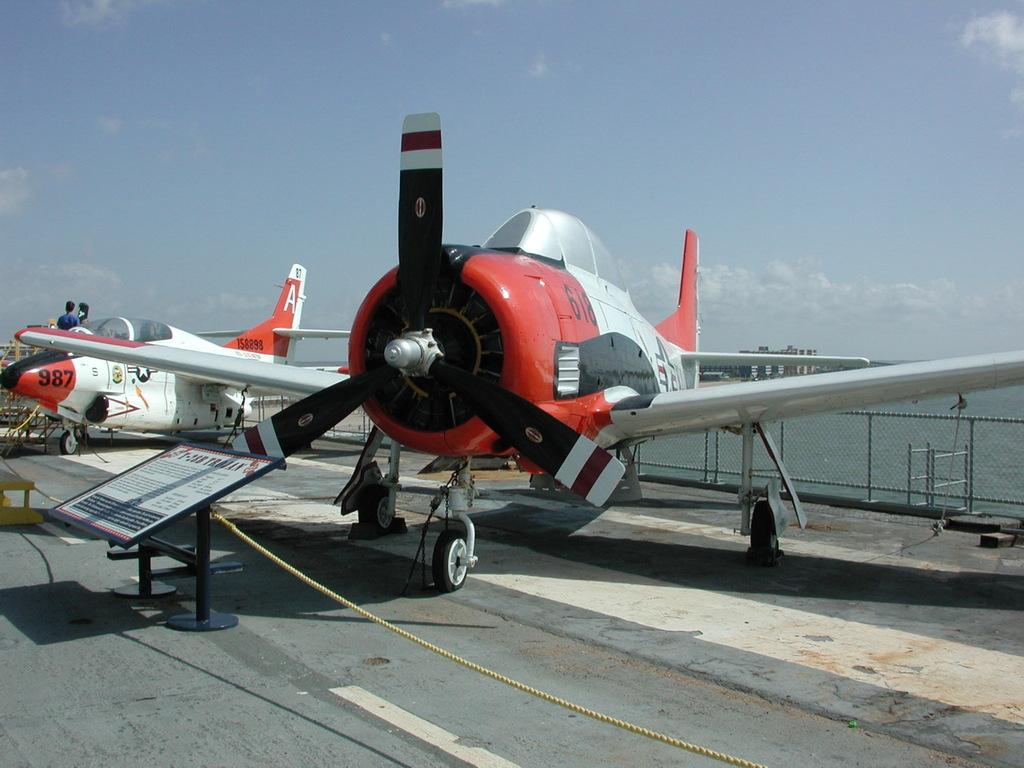<image>
Offer a succinct explanation of the picture presented. The plane in the background is a newer model with the number 987 on the nose. 